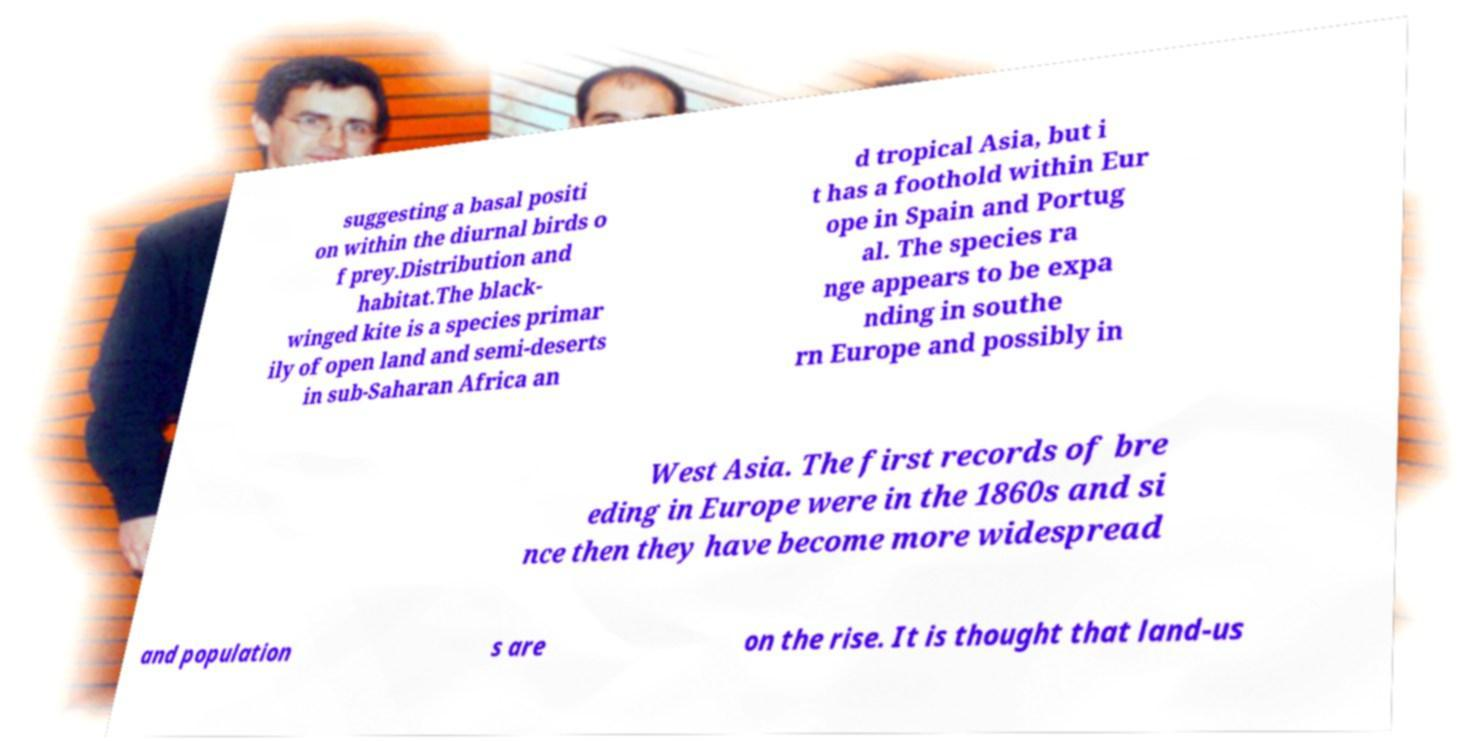For documentation purposes, I need the text within this image transcribed. Could you provide that? suggesting a basal positi on within the diurnal birds o f prey.Distribution and habitat.The black- winged kite is a species primar ily of open land and semi-deserts in sub-Saharan Africa an d tropical Asia, but i t has a foothold within Eur ope in Spain and Portug al. The species ra nge appears to be expa nding in southe rn Europe and possibly in West Asia. The first records of bre eding in Europe were in the 1860s and si nce then they have become more widespread and population s are on the rise. It is thought that land-us 